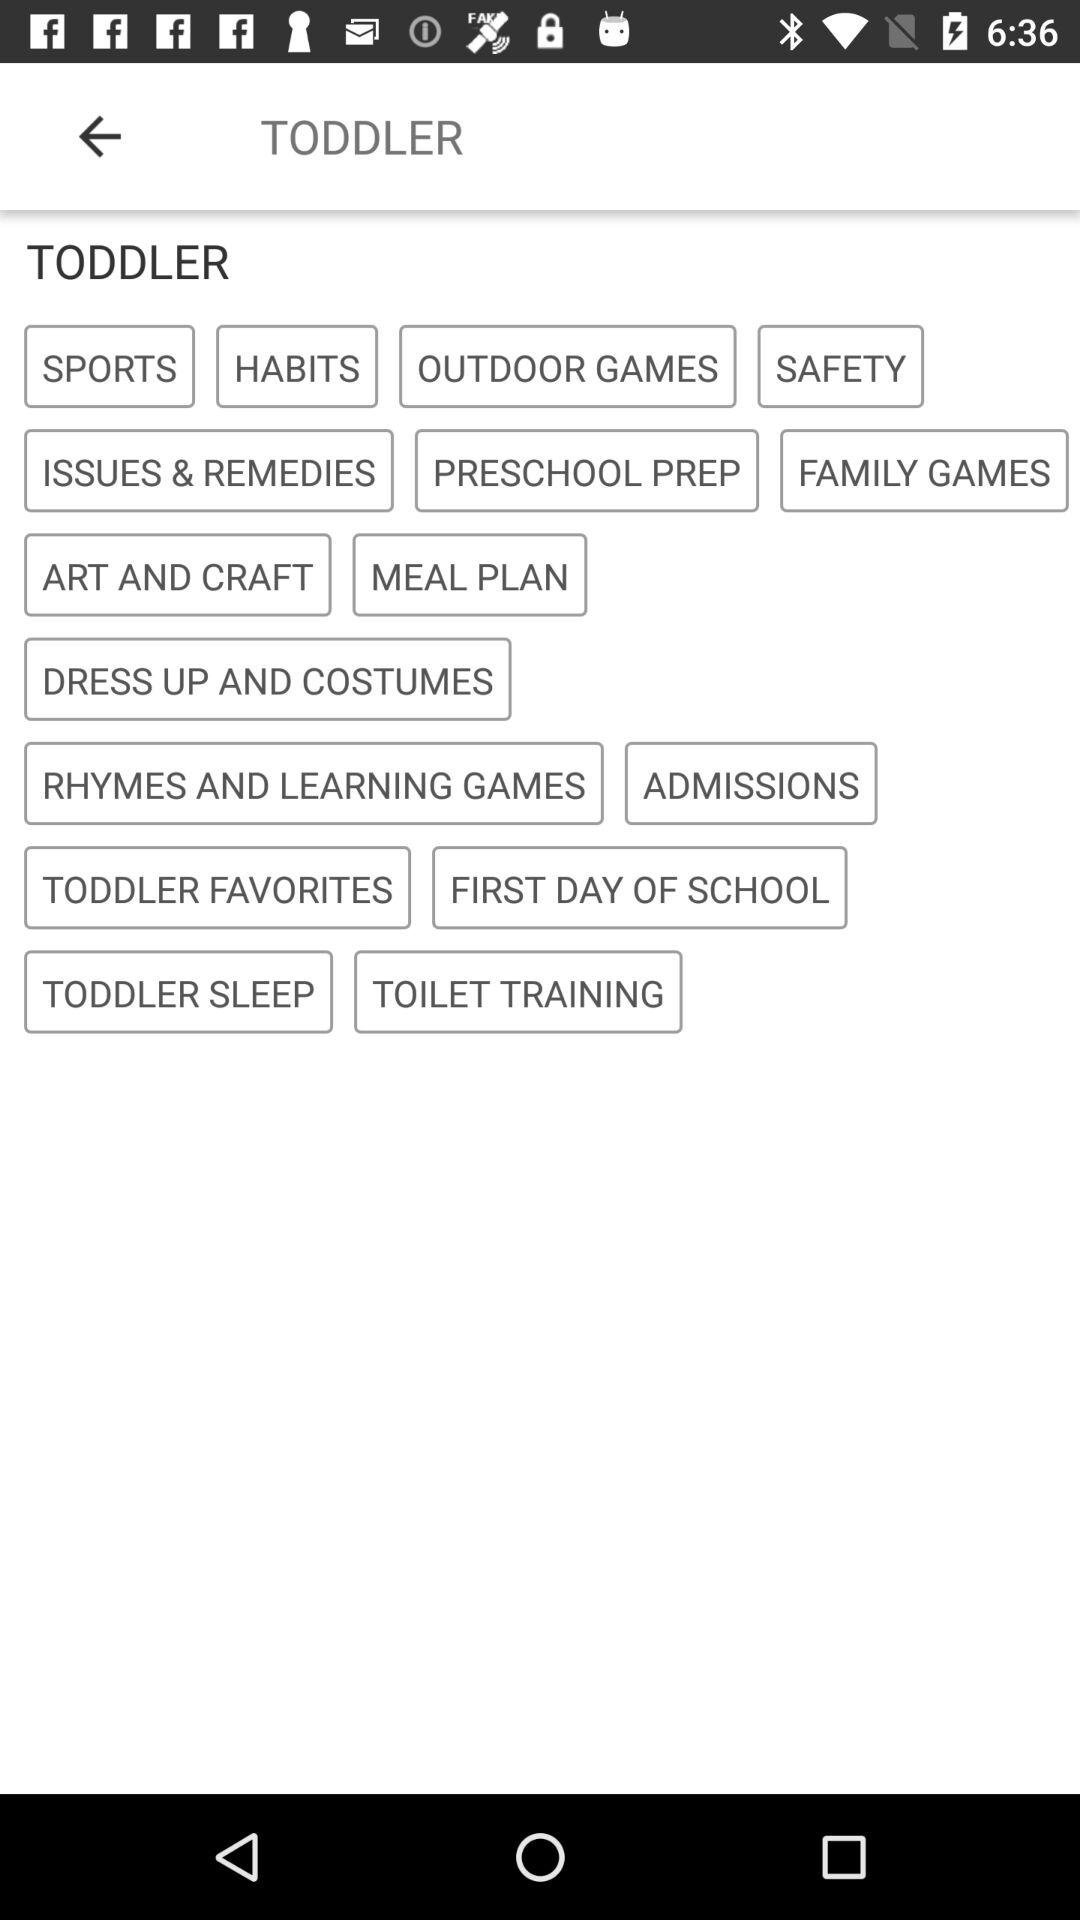What is the app name?
When the provided information is insufficient, respond with <no answer>. <no answer> 